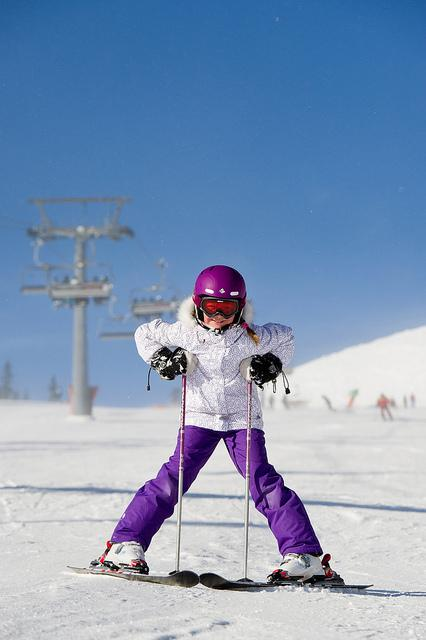What is the girl using the poles to do?

Choices:
A) stand up
B) climb
C) dig
D) reach stand up 